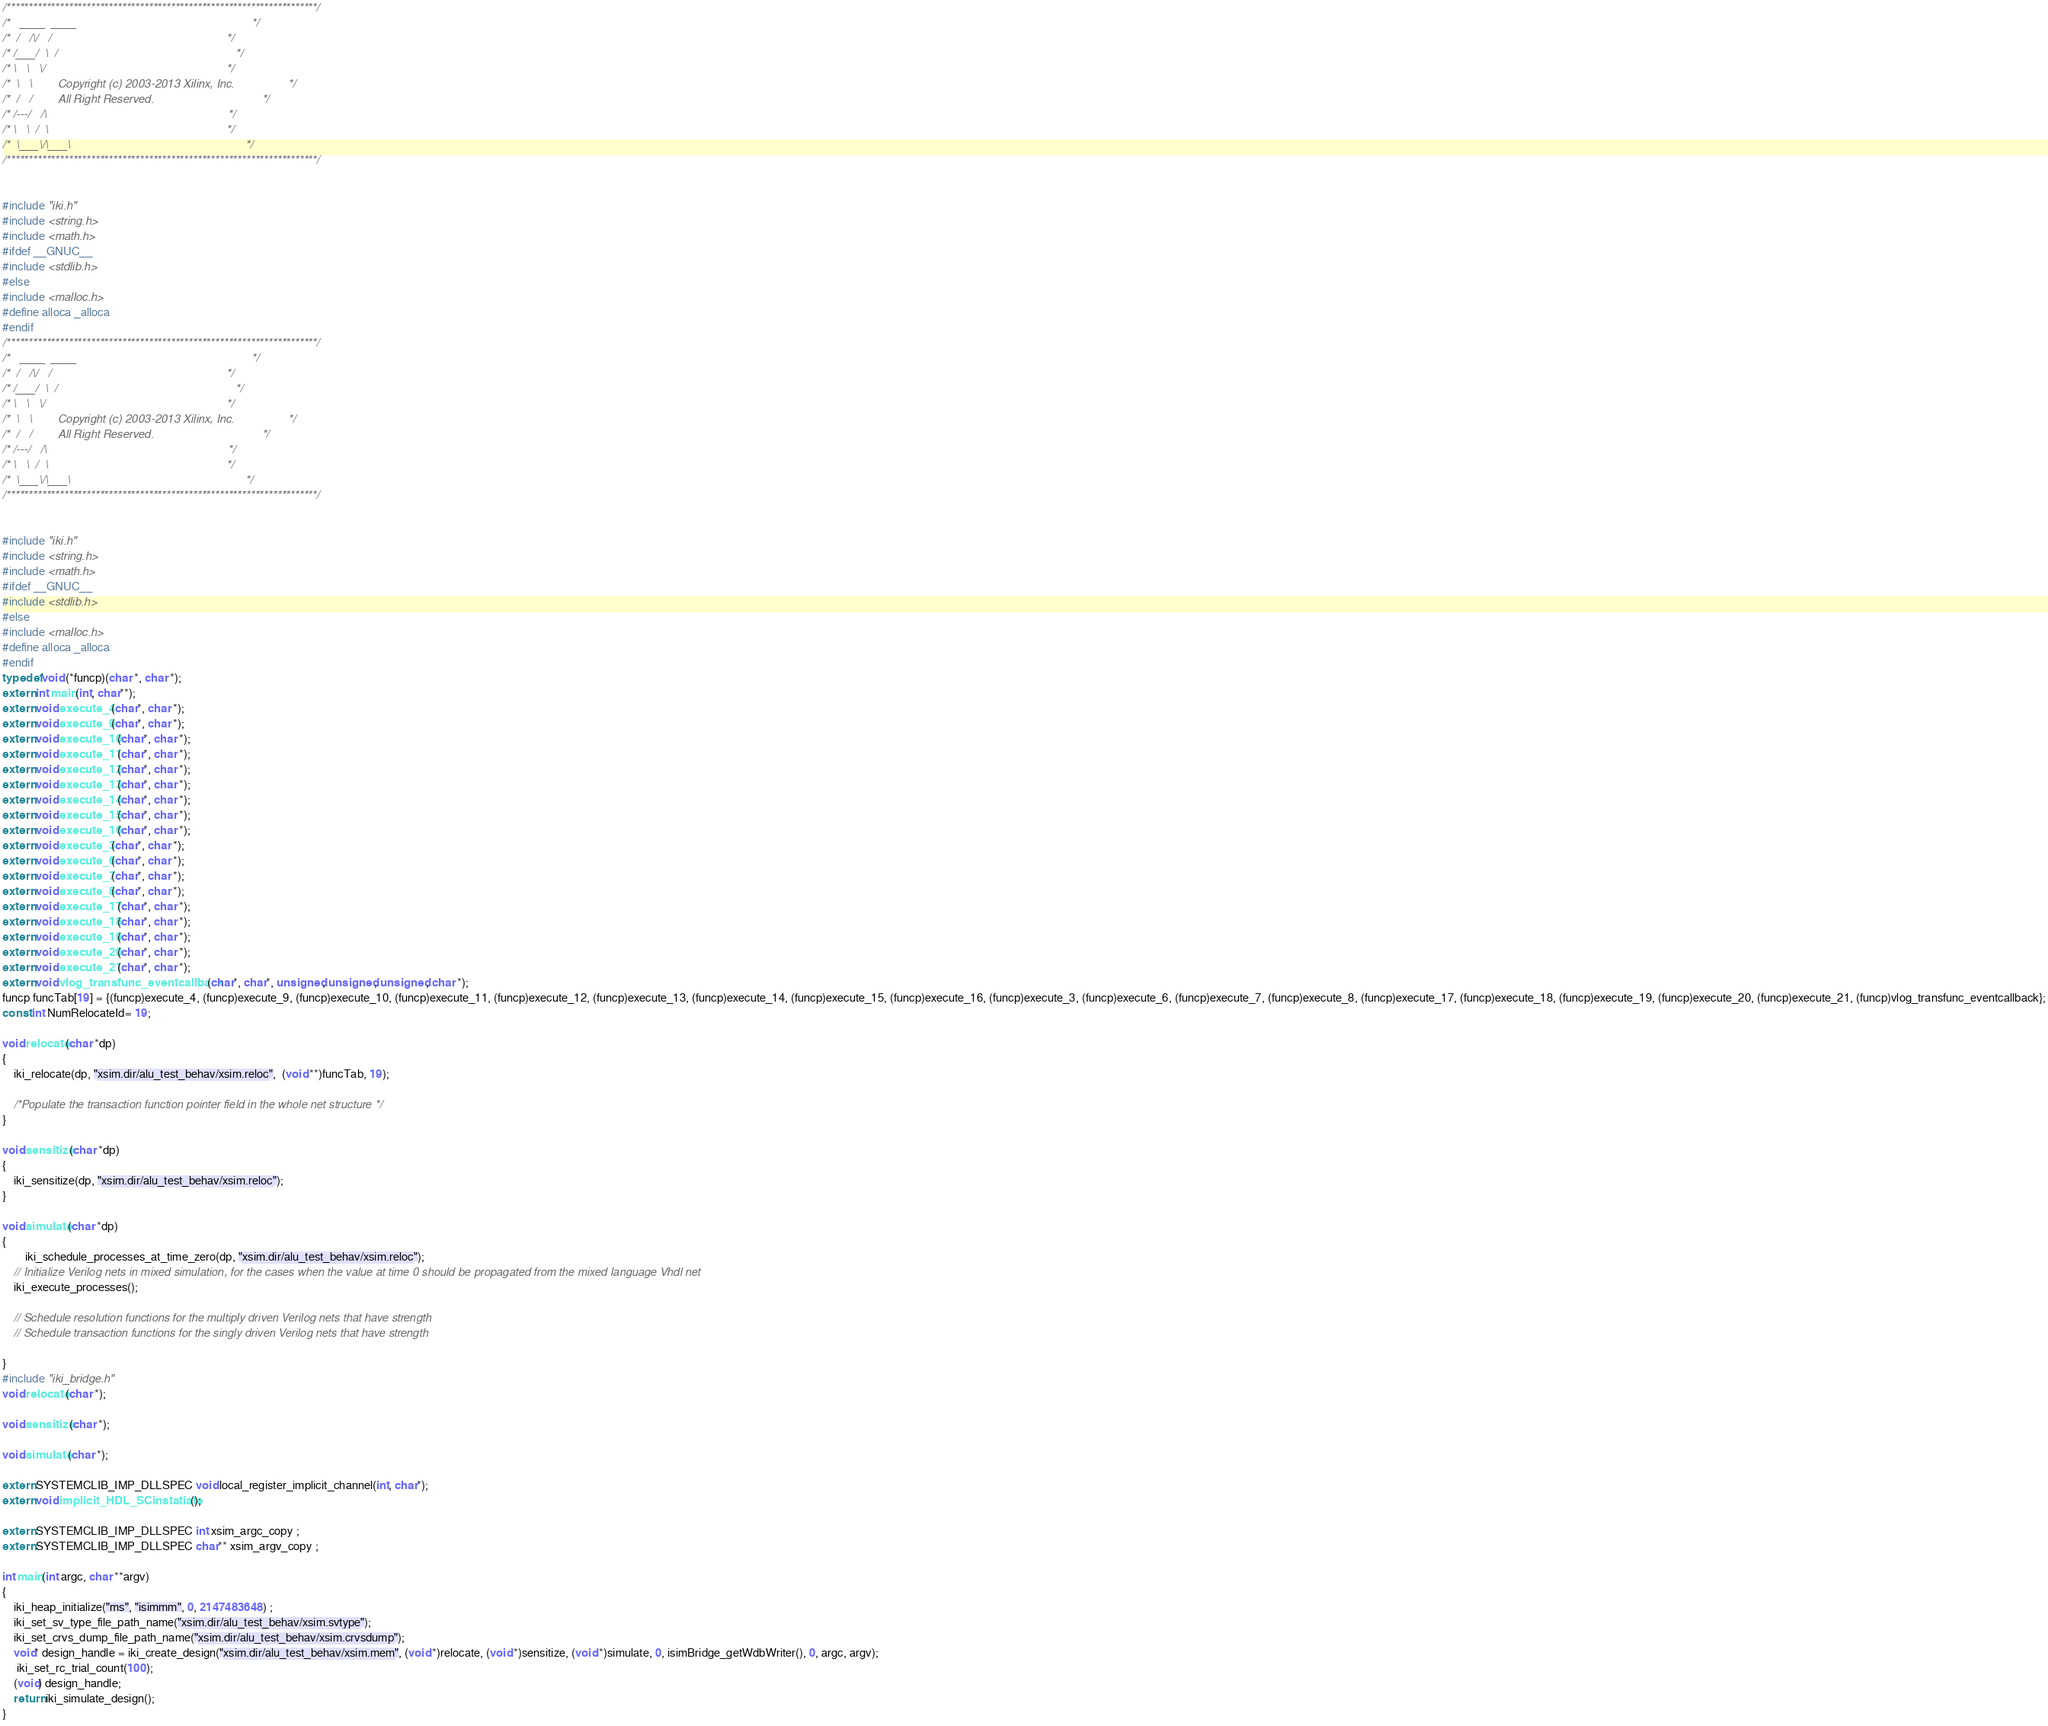Convert code to text. <code><loc_0><loc_0><loc_500><loc_500><_C_>/**********************************************************************/
/*   ____  ____                                                       */
/*  /   /\/   /                                                       */
/* /___/  \  /                                                        */
/* \   \   \/                                                         */
/*  \   \        Copyright (c) 2003-2013 Xilinx, Inc.                 */
/*  /   /        All Right Reserved.                                  */
/* /---/   /\                                                         */
/* \   \  /  \                                                        */
/*  \___\/\___\                                                       */
/**********************************************************************/


#include "iki.h"
#include <string.h>
#include <math.h>
#ifdef __GNUC__
#include <stdlib.h>
#else
#include <malloc.h>
#define alloca _alloca
#endif
/**********************************************************************/
/*   ____  ____                                                       */
/*  /   /\/   /                                                       */
/* /___/  \  /                                                        */
/* \   \   \/                                                         */
/*  \   \        Copyright (c) 2003-2013 Xilinx, Inc.                 */
/*  /   /        All Right Reserved.                                  */
/* /---/   /\                                                         */
/* \   \  /  \                                                        */
/*  \___\/\___\                                                       */
/**********************************************************************/


#include "iki.h"
#include <string.h>
#include <math.h>
#ifdef __GNUC__
#include <stdlib.h>
#else
#include <malloc.h>
#define alloca _alloca
#endif
typedef void (*funcp)(char *, char *);
extern int main(int, char**);
extern void execute_4(char*, char *);
extern void execute_9(char*, char *);
extern void execute_10(char*, char *);
extern void execute_11(char*, char *);
extern void execute_12(char*, char *);
extern void execute_13(char*, char *);
extern void execute_14(char*, char *);
extern void execute_15(char*, char *);
extern void execute_16(char*, char *);
extern void execute_3(char*, char *);
extern void execute_6(char*, char *);
extern void execute_7(char*, char *);
extern void execute_8(char*, char *);
extern void execute_17(char*, char *);
extern void execute_18(char*, char *);
extern void execute_19(char*, char *);
extern void execute_20(char*, char *);
extern void execute_21(char*, char *);
extern void vlog_transfunc_eventcallback(char*, char*, unsigned, unsigned, unsigned, char *);
funcp funcTab[19] = {(funcp)execute_4, (funcp)execute_9, (funcp)execute_10, (funcp)execute_11, (funcp)execute_12, (funcp)execute_13, (funcp)execute_14, (funcp)execute_15, (funcp)execute_16, (funcp)execute_3, (funcp)execute_6, (funcp)execute_7, (funcp)execute_8, (funcp)execute_17, (funcp)execute_18, (funcp)execute_19, (funcp)execute_20, (funcp)execute_21, (funcp)vlog_transfunc_eventcallback};
const int NumRelocateId= 19;

void relocate(char *dp)
{
	iki_relocate(dp, "xsim.dir/alu_test_behav/xsim.reloc",  (void **)funcTab, 19);

	/*Populate the transaction function pointer field in the whole net structure */
}

void sensitize(char *dp)
{
	iki_sensitize(dp, "xsim.dir/alu_test_behav/xsim.reloc");
}

void simulate(char *dp)
{
		iki_schedule_processes_at_time_zero(dp, "xsim.dir/alu_test_behav/xsim.reloc");
	// Initialize Verilog nets in mixed simulation, for the cases when the value at time 0 should be propagated from the mixed language Vhdl net
	iki_execute_processes();

	// Schedule resolution functions for the multiply driven Verilog nets that have strength
	// Schedule transaction functions for the singly driven Verilog nets that have strength

}
#include "iki_bridge.h"
void relocate(char *);

void sensitize(char *);

void simulate(char *);

extern SYSTEMCLIB_IMP_DLLSPEC void local_register_implicit_channel(int, char*);
extern void implicit_HDL_SCinstatiate();

extern SYSTEMCLIB_IMP_DLLSPEC int xsim_argc_copy ;
extern SYSTEMCLIB_IMP_DLLSPEC char** xsim_argv_copy ;

int main(int argc, char **argv)
{
    iki_heap_initialize("ms", "isimmm", 0, 2147483648) ;
    iki_set_sv_type_file_path_name("xsim.dir/alu_test_behav/xsim.svtype");
    iki_set_crvs_dump_file_path_name("xsim.dir/alu_test_behav/xsim.crvsdump");
    void* design_handle = iki_create_design("xsim.dir/alu_test_behav/xsim.mem", (void *)relocate, (void *)sensitize, (void *)simulate, 0, isimBridge_getWdbWriter(), 0, argc, argv);
     iki_set_rc_trial_count(100);
    (void) design_handle;
    return iki_simulate_design();
}
</code> 